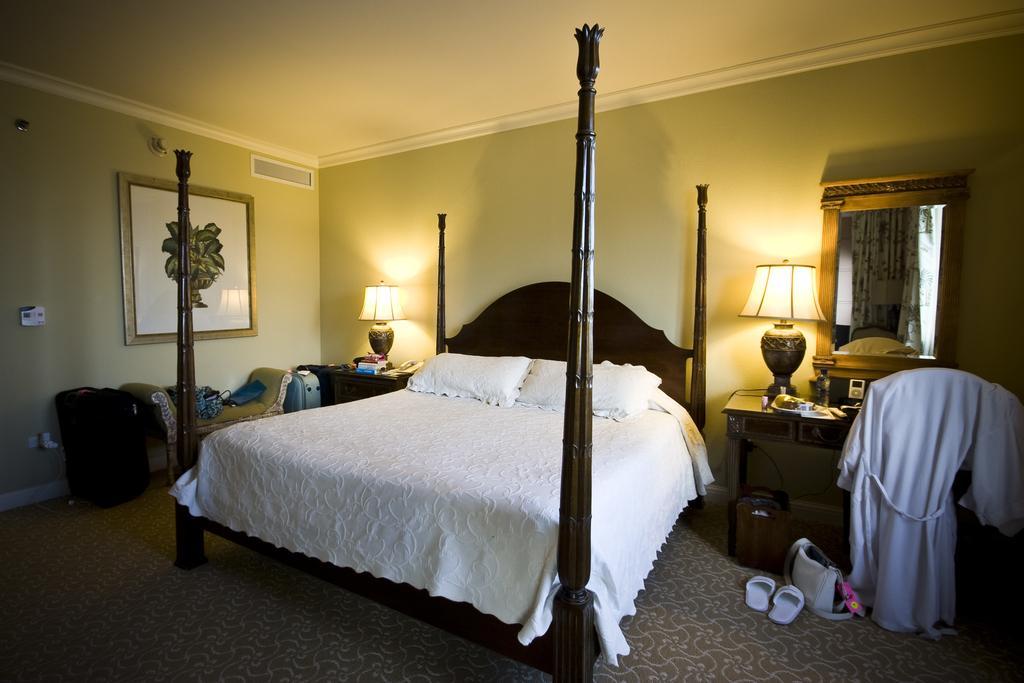Can you describe this image briefly? This is the inside view of a bedroom where we can see bed. Beside bed we can see table and lamps are there. Right side of the image one mirror is there, in front of the mirror chair and white color bath gown is present. Left side of the image sofa and bag is there. The wall is in yellow color and the roof is in white color. To the left side of the image one frame is available and near the chair one bag, slippers and one more thing is present. 